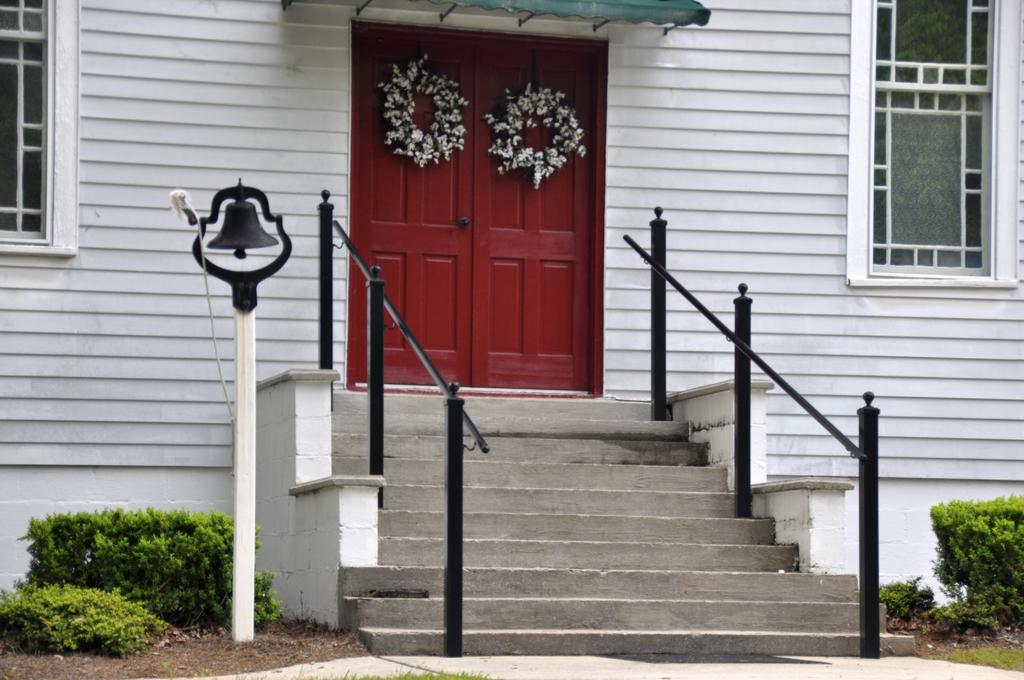What type of structure can be seen in the image? There are stairs in the image. What type of vegetation is present in the image? There are green color plants in the image. How many doors are visible in the image? There are two red color doors in the image. What color is the wall in the image? There is a white color wall in the image. How many windows are present in the image? There are two windows in the image. What force is responsible for the birth of the plants in the image? The image does not provide information about the force responsible for the birth of the plants, nor does it show any plants being born. 